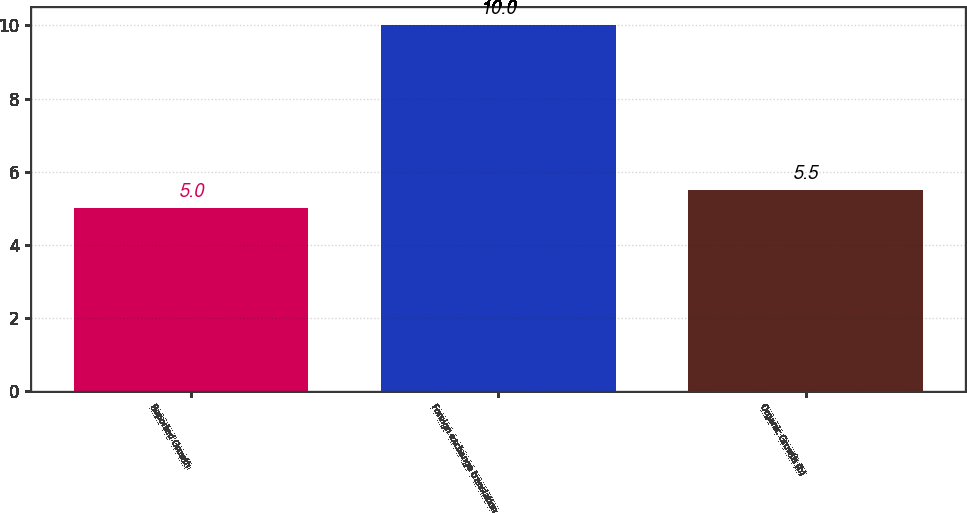Convert chart to OTSL. <chart><loc_0><loc_0><loc_500><loc_500><bar_chart><fcel>Reported Growth<fcel>Foreign exchange translation<fcel>Organic Growth (b)<nl><fcel>5<fcel>10<fcel>5.5<nl></chart> 